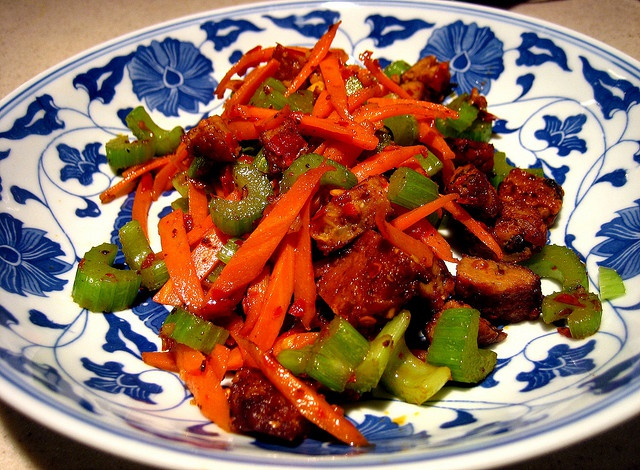Describe the objects in this image and their specific colors. I can see bowl in ivory, gray, maroon, and black tones, carrot in gray, red, and maroon tones, carrot in gray, red, brown, and maroon tones, carrot in gray, red, brown, and maroon tones, and carrot in gray, red, brown, and orange tones in this image. 